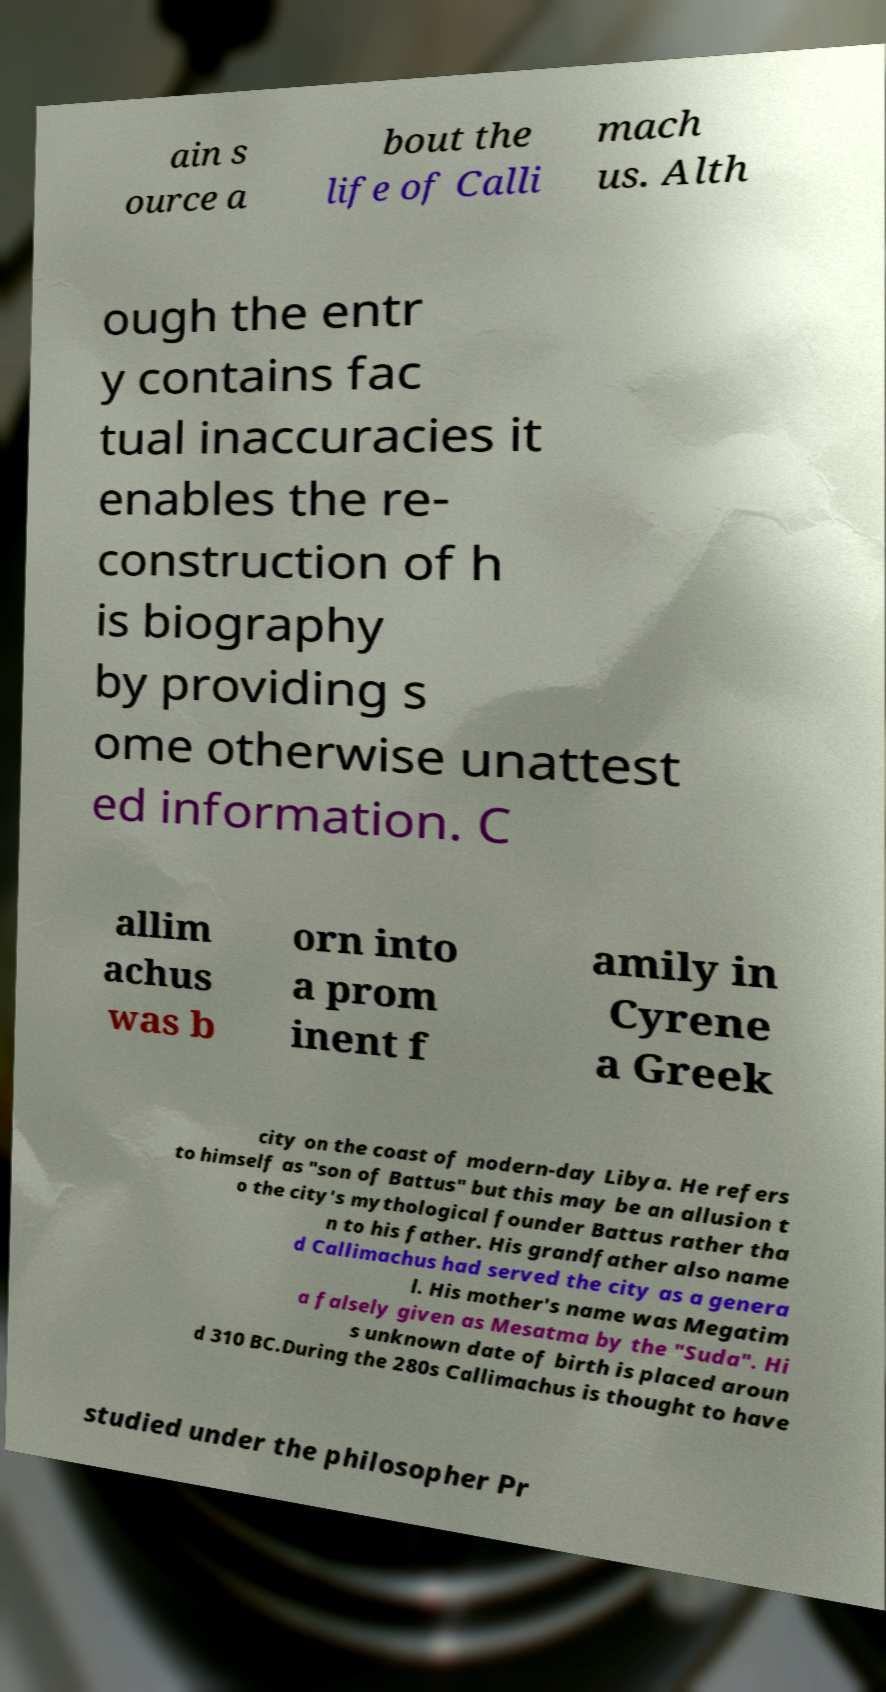There's text embedded in this image that I need extracted. Can you transcribe it verbatim? ain s ource a bout the life of Calli mach us. Alth ough the entr y contains fac tual inaccuracies it enables the re- construction of h is biography by providing s ome otherwise unattest ed information. C allim achus was b orn into a prom inent f amily in Cyrene a Greek city on the coast of modern-day Libya. He refers to himself as "son of Battus" but this may be an allusion t o the city's mythological founder Battus rather tha n to his father. His grandfather also name d Callimachus had served the city as a genera l. His mother's name was Megatim a falsely given as Mesatma by the "Suda". Hi s unknown date of birth is placed aroun d 310 BC.During the 280s Callimachus is thought to have studied under the philosopher Pr 